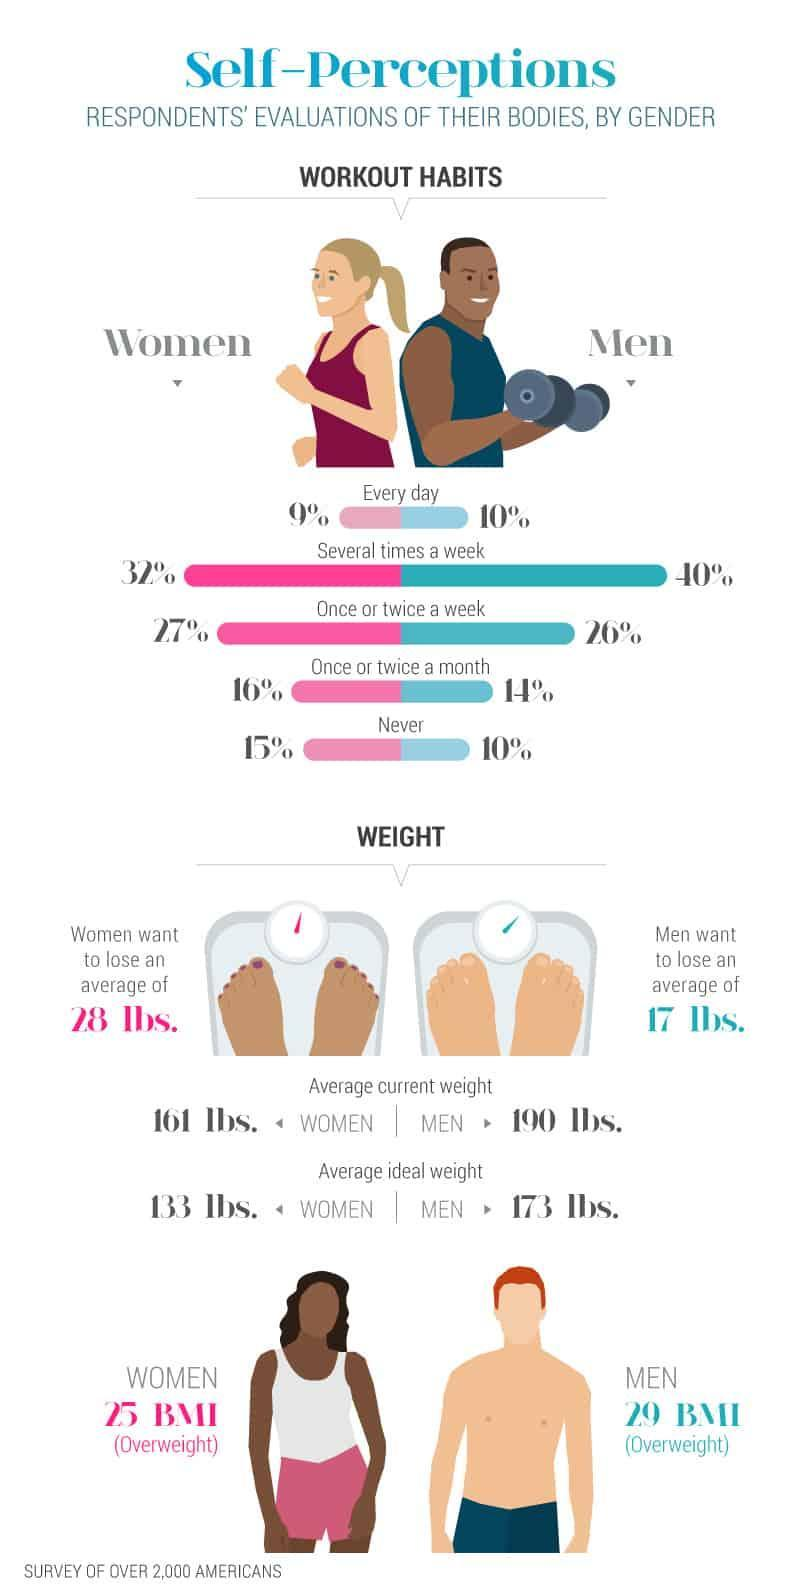What is the difference in percentage of men and women who work out several times a week?
Answer the question with a short phrase. 8% What is the ratio of women who do not work out? 3 : 20 What is the average weight men want to reduce, 17 lbs, 28 lbs, or 161 lbs? 17 lbs What is the body mass index of women who are above the normal weight, 29, 28, or 25? 25 What percentage of men have a daily regime for workout, 9%, 10%, or 40%? 10% 